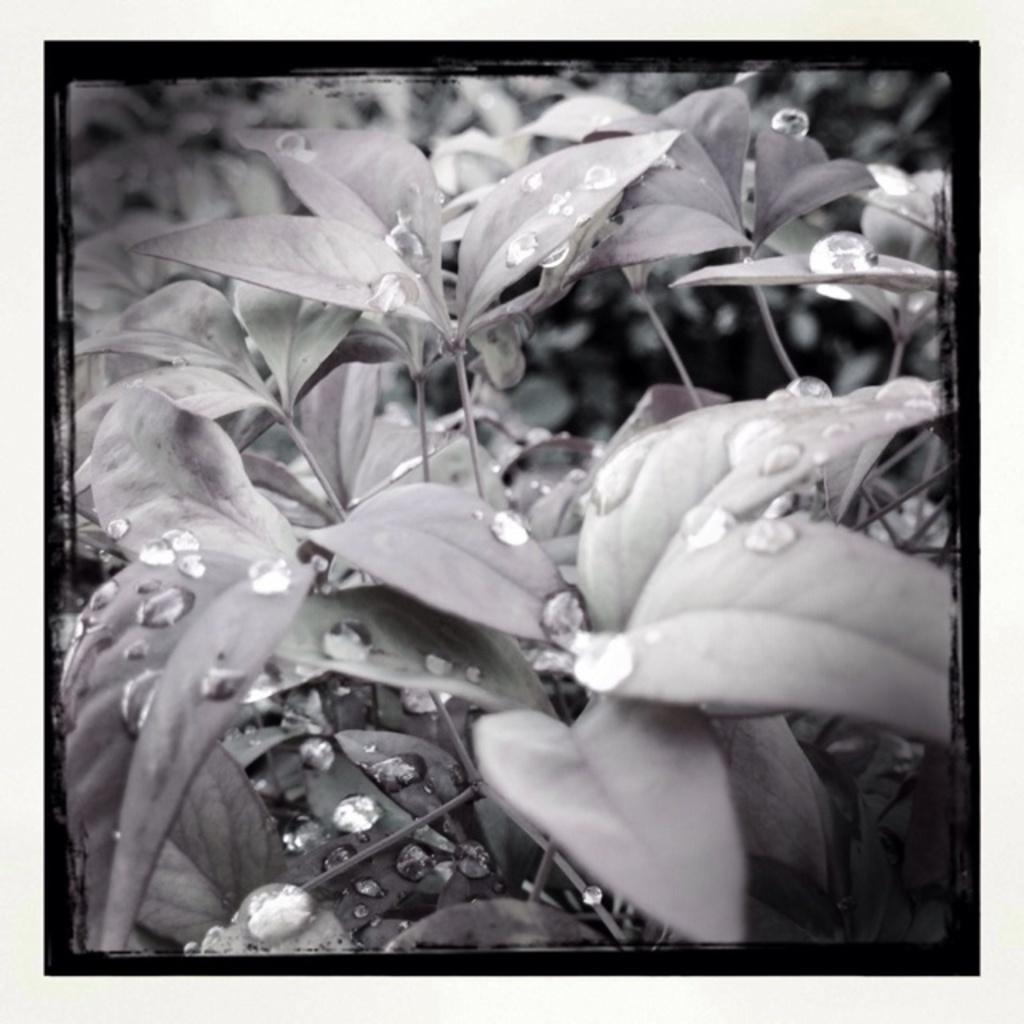Can you describe this image briefly? In this image there are leaves, water droplets and stems. 